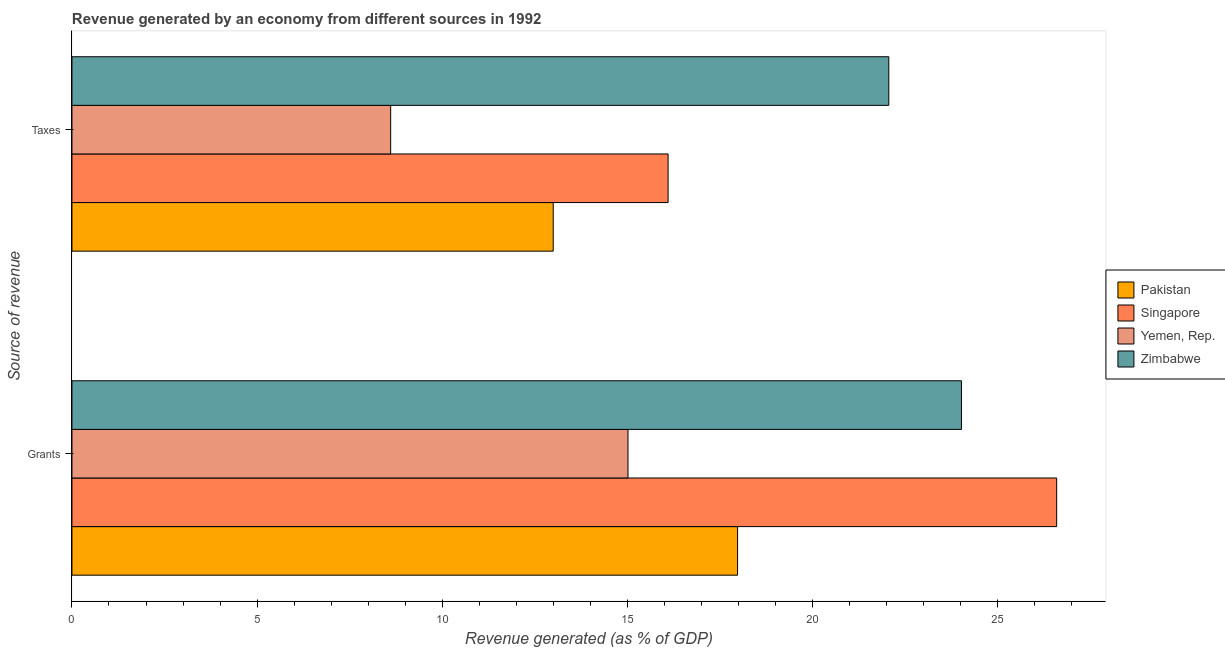How many groups of bars are there?
Offer a very short reply. 2. Are the number of bars on each tick of the Y-axis equal?
Keep it short and to the point. Yes. What is the label of the 1st group of bars from the top?
Your answer should be compact. Taxes. What is the revenue generated by taxes in Pakistan?
Provide a succinct answer. 12.99. Across all countries, what is the maximum revenue generated by grants?
Offer a terse response. 26.59. Across all countries, what is the minimum revenue generated by taxes?
Offer a very short reply. 8.61. In which country was the revenue generated by taxes maximum?
Provide a short and direct response. Zimbabwe. In which country was the revenue generated by taxes minimum?
Provide a short and direct response. Yemen, Rep. What is the total revenue generated by grants in the graph?
Provide a short and direct response. 83.59. What is the difference between the revenue generated by grants in Singapore and that in Pakistan?
Your answer should be very brief. 8.62. What is the difference between the revenue generated by taxes in Zimbabwe and the revenue generated by grants in Yemen, Rep.?
Make the answer very short. 7.04. What is the average revenue generated by grants per country?
Your response must be concise. 20.9. What is the difference between the revenue generated by taxes and revenue generated by grants in Zimbabwe?
Your response must be concise. -1.96. In how many countries, is the revenue generated by grants greater than 26 %?
Keep it short and to the point. 1. What is the ratio of the revenue generated by grants in Yemen, Rep. to that in Singapore?
Make the answer very short. 0.56. Is the revenue generated by taxes in Yemen, Rep. less than that in Zimbabwe?
Provide a short and direct response. Yes. In how many countries, is the revenue generated by grants greater than the average revenue generated by grants taken over all countries?
Give a very brief answer. 2. What does the 1st bar from the top in Taxes represents?
Provide a succinct answer. Zimbabwe. What does the 4th bar from the bottom in Taxes represents?
Provide a succinct answer. Zimbabwe. How many bars are there?
Provide a short and direct response. 8. Are all the bars in the graph horizontal?
Make the answer very short. Yes. How many countries are there in the graph?
Make the answer very short. 4. What is the difference between two consecutive major ticks on the X-axis?
Offer a very short reply. 5. Does the graph contain any zero values?
Ensure brevity in your answer.  No. Where does the legend appear in the graph?
Provide a short and direct response. Center right. How are the legend labels stacked?
Offer a terse response. Vertical. What is the title of the graph?
Keep it short and to the point. Revenue generated by an economy from different sources in 1992. Does "Barbados" appear as one of the legend labels in the graph?
Provide a short and direct response. No. What is the label or title of the X-axis?
Your answer should be very brief. Revenue generated (as % of GDP). What is the label or title of the Y-axis?
Make the answer very short. Source of revenue. What is the Revenue generated (as % of GDP) of Pakistan in Grants?
Keep it short and to the point. 17.97. What is the Revenue generated (as % of GDP) of Singapore in Grants?
Your answer should be very brief. 26.59. What is the Revenue generated (as % of GDP) in Yemen, Rep. in Grants?
Your response must be concise. 15.01. What is the Revenue generated (as % of GDP) in Zimbabwe in Grants?
Offer a terse response. 24.02. What is the Revenue generated (as % of GDP) of Pakistan in Taxes?
Your response must be concise. 12.99. What is the Revenue generated (as % of GDP) in Singapore in Taxes?
Your response must be concise. 16.1. What is the Revenue generated (as % of GDP) of Yemen, Rep. in Taxes?
Provide a short and direct response. 8.61. What is the Revenue generated (as % of GDP) in Zimbabwe in Taxes?
Give a very brief answer. 22.05. Across all Source of revenue, what is the maximum Revenue generated (as % of GDP) of Pakistan?
Keep it short and to the point. 17.97. Across all Source of revenue, what is the maximum Revenue generated (as % of GDP) of Singapore?
Give a very brief answer. 26.59. Across all Source of revenue, what is the maximum Revenue generated (as % of GDP) of Yemen, Rep.?
Your answer should be compact. 15.01. Across all Source of revenue, what is the maximum Revenue generated (as % of GDP) of Zimbabwe?
Keep it short and to the point. 24.02. Across all Source of revenue, what is the minimum Revenue generated (as % of GDP) in Pakistan?
Offer a terse response. 12.99. Across all Source of revenue, what is the minimum Revenue generated (as % of GDP) of Singapore?
Provide a succinct answer. 16.1. Across all Source of revenue, what is the minimum Revenue generated (as % of GDP) of Yemen, Rep.?
Ensure brevity in your answer.  8.61. Across all Source of revenue, what is the minimum Revenue generated (as % of GDP) of Zimbabwe?
Your answer should be compact. 22.05. What is the total Revenue generated (as % of GDP) in Pakistan in the graph?
Your answer should be very brief. 30.96. What is the total Revenue generated (as % of GDP) of Singapore in the graph?
Keep it short and to the point. 42.68. What is the total Revenue generated (as % of GDP) in Yemen, Rep. in the graph?
Give a very brief answer. 23.62. What is the total Revenue generated (as % of GDP) of Zimbabwe in the graph?
Give a very brief answer. 46.07. What is the difference between the Revenue generated (as % of GDP) of Pakistan in Grants and that in Taxes?
Offer a terse response. 4.98. What is the difference between the Revenue generated (as % of GDP) of Singapore in Grants and that in Taxes?
Give a very brief answer. 10.49. What is the difference between the Revenue generated (as % of GDP) of Yemen, Rep. in Grants and that in Taxes?
Keep it short and to the point. 6.41. What is the difference between the Revenue generated (as % of GDP) of Zimbabwe in Grants and that in Taxes?
Make the answer very short. 1.96. What is the difference between the Revenue generated (as % of GDP) of Pakistan in Grants and the Revenue generated (as % of GDP) of Singapore in Taxes?
Your answer should be compact. 1.88. What is the difference between the Revenue generated (as % of GDP) in Pakistan in Grants and the Revenue generated (as % of GDP) in Yemen, Rep. in Taxes?
Offer a terse response. 9.37. What is the difference between the Revenue generated (as % of GDP) of Pakistan in Grants and the Revenue generated (as % of GDP) of Zimbabwe in Taxes?
Keep it short and to the point. -4.08. What is the difference between the Revenue generated (as % of GDP) of Singapore in Grants and the Revenue generated (as % of GDP) of Yemen, Rep. in Taxes?
Give a very brief answer. 17.98. What is the difference between the Revenue generated (as % of GDP) in Singapore in Grants and the Revenue generated (as % of GDP) in Zimbabwe in Taxes?
Your answer should be compact. 4.53. What is the difference between the Revenue generated (as % of GDP) of Yemen, Rep. in Grants and the Revenue generated (as % of GDP) of Zimbabwe in Taxes?
Keep it short and to the point. -7.04. What is the average Revenue generated (as % of GDP) of Pakistan per Source of revenue?
Provide a short and direct response. 15.48. What is the average Revenue generated (as % of GDP) of Singapore per Source of revenue?
Provide a short and direct response. 21.34. What is the average Revenue generated (as % of GDP) of Yemen, Rep. per Source of revenue?
Provide a succinct answer. 11.81. What is the average Revenue generated (as % of GDP) of Zimbabwe per Source of revenue?
Provide a short and direct response. 23.04. What is the difference between the Revenue generated (as % of GDP) of Pakistan and Revenue generated (as % of GDP) of Singapore in Grants?
Ensure brevity in your answer.  -8.62. What is the difference between the Revenue generated (as % of GDP) of Pakistan and Revenue generated (as % of GDP) of Yemen, Rep. in Grants?
Give a very brief answer. 2.96. What is the difference between the Revenue generated (as % of GDP) of Pakistan and Revenue generated (as % of GDP) of Zimbabwe in Grants?
Keep it short and to the point. -6.04. What is the difference between the Revenue generated (as % of GDP) in Singapore and Revenue generated (as % of GDP) in Yemen, Rep. in Grants?
Provide a succinct answer. 11.57. What is the difference between the Revenue generated (as % of GDP) of Singapore and Revenue generated (as % of GDP) of Zimbabwe in Grants?
Provide a short and direct response. 2.57. What is the difference between the Revenue generated (as % of GDP) of Yemen, Rep. and Revenue generated (as % of GDP) of Zimbabwe in Grants?
Make the answer very short. -9. What is the difference between the Revenue generated (as % of GDP) in Pakistan and Revenue generated (as % of GDP) in Singapore in Taxes?
Your answer should be compact. -3.1. What is the difference between the Revenue generated (as % of GDP) in Pakistan and Revenue generated (as % of GDP) in Yemen, Rep. in Taxes?
Your response must be concise. 4.39. What is the difference between the Revenue generated (as % of GDP) of Pakistan and Revenue generated (as % of GDP) of Zimbabwe in Taxes?
Offer a terse response. -9.06. What is the difference between the Revenue generated (as % of GDP) of Singapore and Revenue generated (as % of GDP) of Yemen, Rep. in Taxes?
Ensure brevity in your answer.  7.49. What is the difference between the Revenue generated (as % of GDP) in Singapore and Revenue generated (as % of GDP) in Zimbabwe in Taxes?
Your answer should be compact. -5.96. What is the difference between the Revenue generated (as % of GDP) in Yemen, Rep. and Revenue generated (as % of GDP) in Zimbabwe in Taxes?
Offer a terse response. -13.45. What is the ratio of the Revenue generated (as % of GDP) of Pakistan in Grants to that in Taxes?
Offer a very short reply. 1.38. What is the ratio of the Revenue generated (as % of GDP) in Singapore in Grants to that in Taxes?
Offer a very short reply. 1.65. What is the ratio of the Revenue generated (as % of GDP) in Yemen, Rep. in Grants to that in Taxes?
Your response must be concise. 1.74. What is the ratio of the Revenue generated (as % of GDP) of Zimbabwe in Grants to that in Taxes?
Make the answer very short. 1.09. What is the difference between the highest and the second highest Revenue generated (as % of GDP) of Pakistan?
Offer a very short reply. 4.98. What is the difference between the highest and the second highest Revenue generated (as % of GDP) in Singapore?
Offer a very short reply. 10.49. What is the difference between the highest and the second highest Revenue generated (as % of GDP) of Yemen, Rep.?
Give a very brief answer. 6.41. What is the difference between the highest and the second highest Revenue generated (as % of GDP) of Zimbabwe?
Make the answer very short. 1.96. What is the difference between the highest and the lowest Revenue generated (as % of GDP) of Pakistan?
Your response must be concise. 4.98. What is the difference between the highest and the lowest Revenue generated (as % of GDP) of Singapore?
Make the answer very short. 10.49. What is the difference between the highest and the lowest Revenue generated (as % of GDP) of Yemen, Rep.?
Offer a terse response. 6.41. What is the difference between the highest and the lowest Revenue generated (as % of GDP) of Zimbabwe?
Provide a succinct answer. 1.96. 